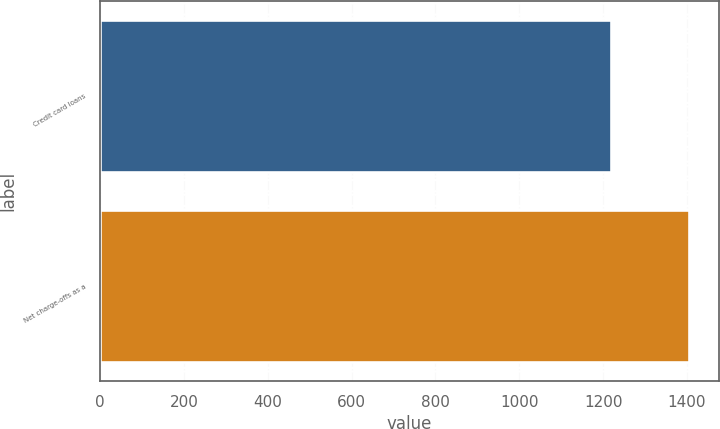Convert chart to OTSL. <chart><loc_0><loc_0><loc_500><loc_500><bar_chart><fcel>Credit card loans<fcel>Net charge-offs as a<nl><fcel>1220<fcel>1405.9<nl></chart> 